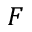Convert formula to latex. <formula><loc_0><loc_0><loc_500><loc_500>F</formula> 